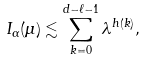<formula> <loc_0><loc_0><loc_500><loc_500>I _ { \alpha } ( \mu ) \lesssim \sum _ { k = 0 } ^ { d - \ell - 1 } \lambda ^ { h ( k ) } ,</formula> 